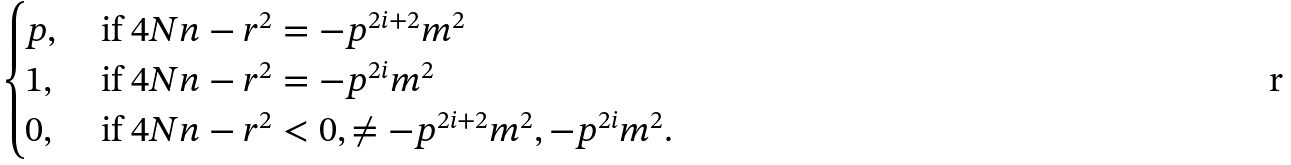Convert formula to latex. <formula><loc_0><loc_0><loc_500><loc_500>\begin{cases} p , & \text { if } 4 N n - r ^ { 2 } = - p ^ { 2 i + 2 } m ^ { 2 } \\ 1 , & \text { if } 4 N n - r ^ { 2 } = - p ^ { 2 i } m ^ { 2 } \\ 0 , & \text { if } 4 N n - r ^ { 2 } < 0 , \neq - p ^ { 2 i + 2 } m ^ { 2 } , - p ^ { 2 i } m ^ { 2 } . \end{cases}</formula> 